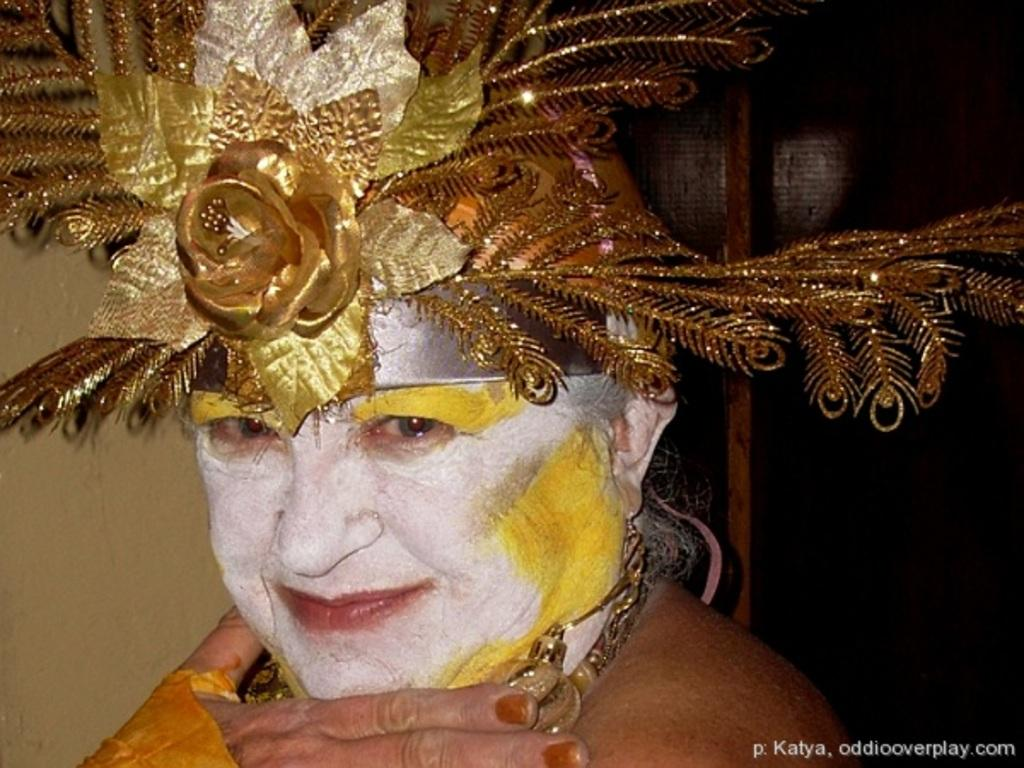What is the person in the image wearing? There is a person wearing a costume in the image. What can be seen in the background of the image? There is a wall in the background of the image. What is located at the bottom of the image? There is text at the bottom of the image. How many ladybugs can be seen on the wall in the image? There are no ladybugs present in the image; only the person in a costume and a wall in the background are visible. 